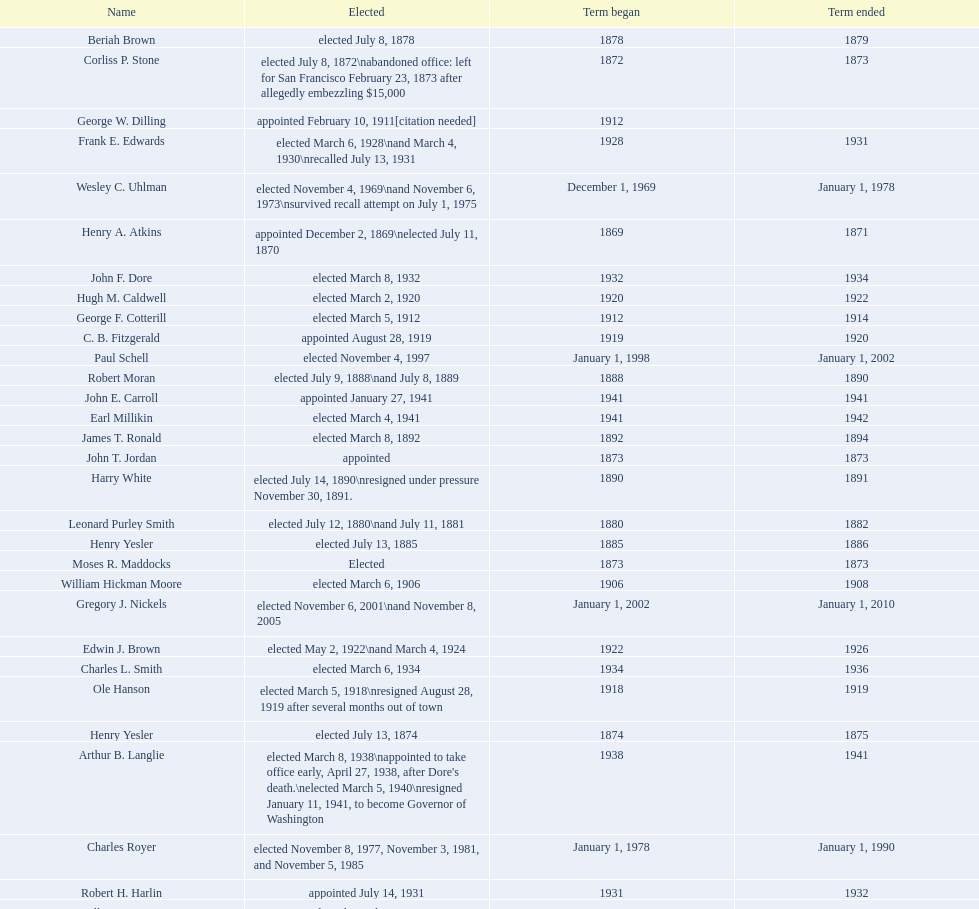Which mayor seattle, washington resigned after only three weeks in office in 1896? Frank D. Black. 